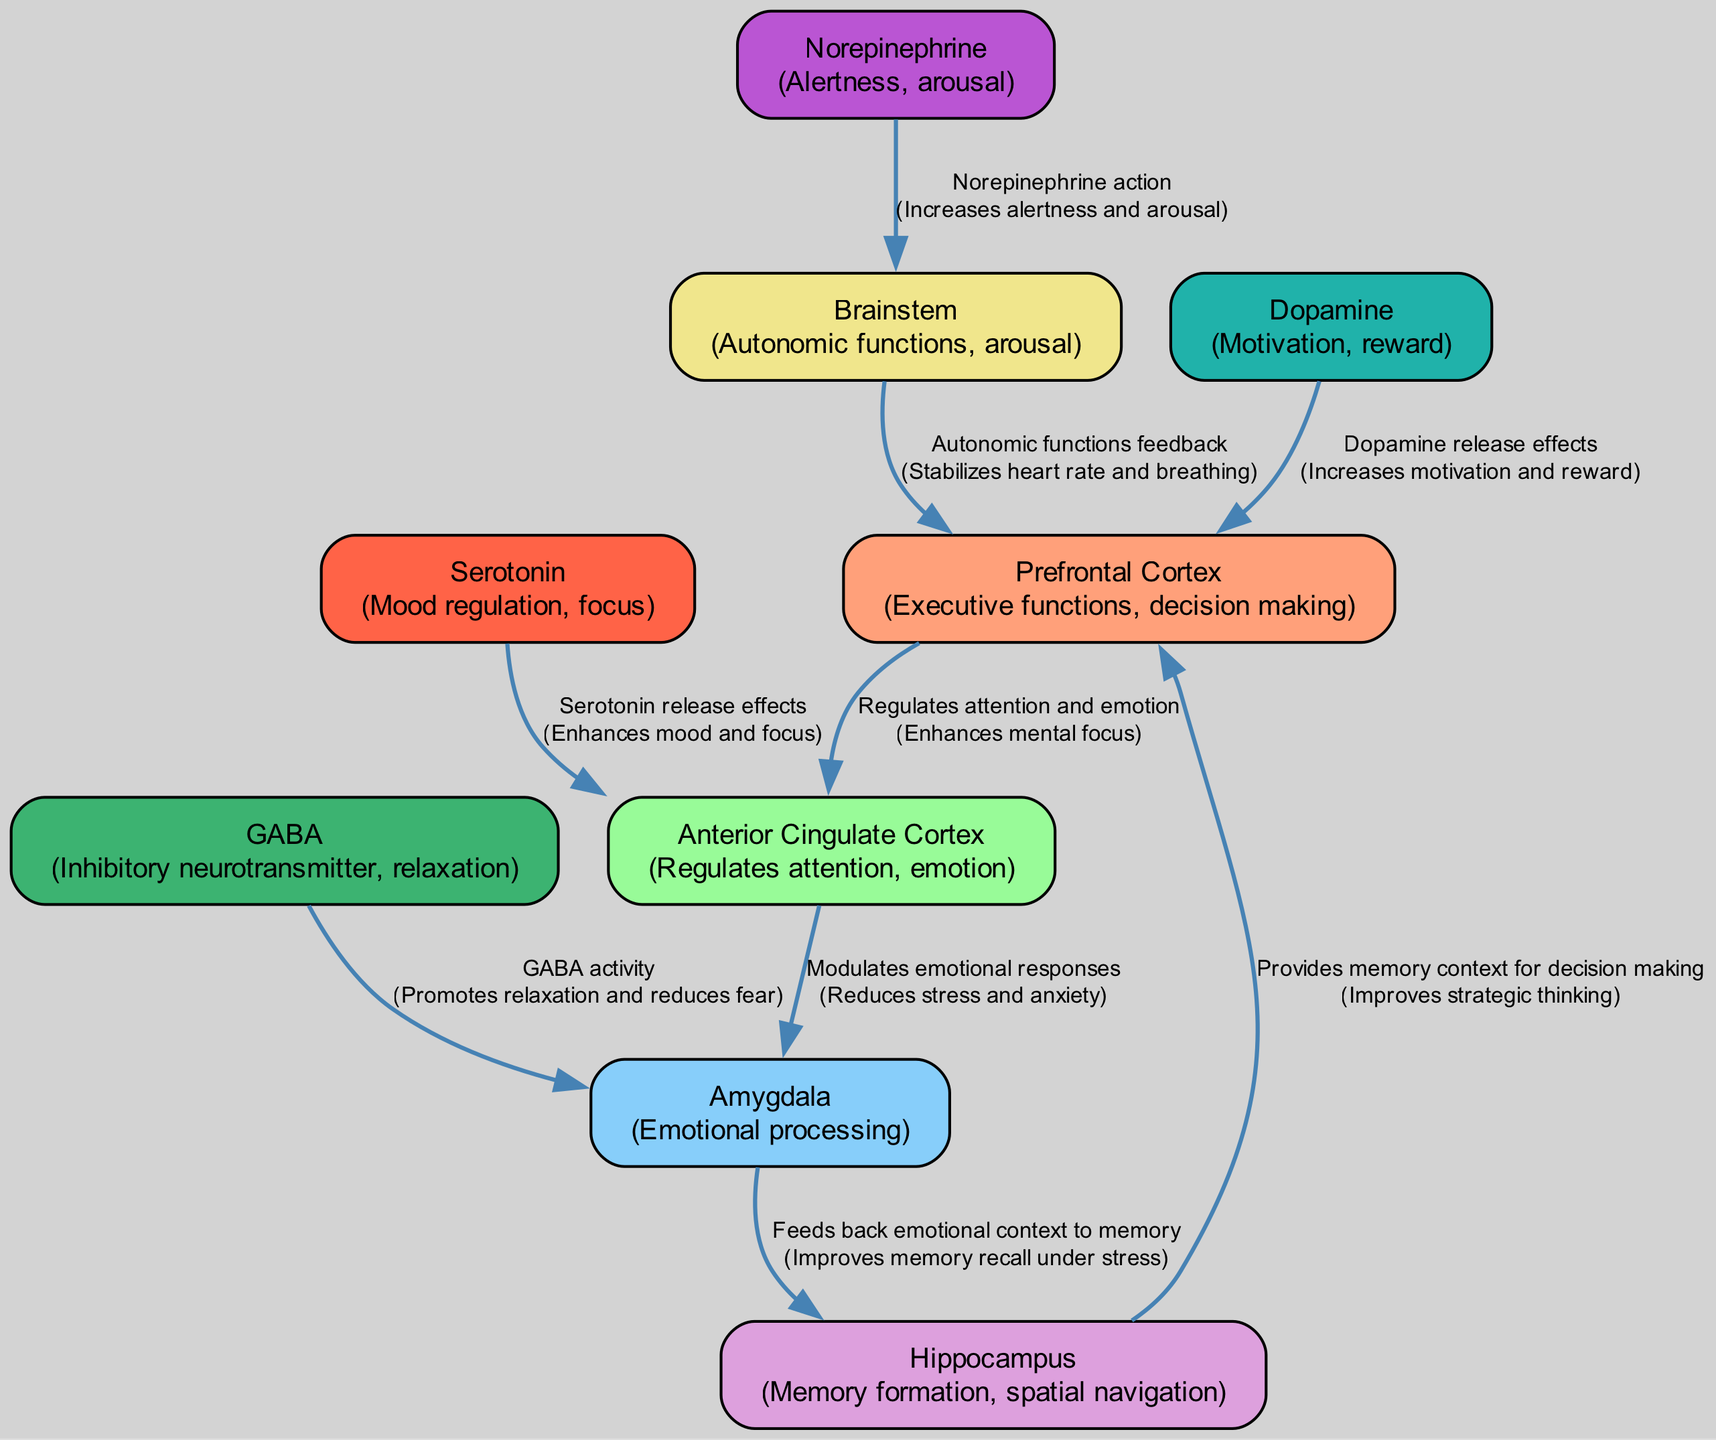What is the function of the Prefrontal Cortex? The Prefrontal Cortex is responsible for executive functions and decision making, as described in the diagram.
Answer: Executive functions, decision making How many nodes are represented in the diagram? The diagram contains 9 nodes, which are the distinct areas or neurotransmitters involved in the neurobiological pathways during meditation.
Answer: 9 What neurotransmitter regulates mood and focus? According to the diagram, Serotonin is the neurotransmitter that regulates mood and focus.
Answer: Serotonin What does the Anterior Cingulate Cortex modulate? The diagram indicates that the Anterior Cingulate Cortex modulates emotional responses.
Answer: Emotional responses Which circuit enhances mental focus? The circuit involving the Prefrontal Cortex and the Anterior Cingulate Cortex enhances mental focus by regulating attention and emotion.
Answer: Prefrontal Cortex to Anterior Cingulate Cortex What feedback does the Brainstem provide? The Brainstem provides autonomic functions feedback, which helps stabilize heart rate and breathing in a meditative state.
Answer: Autonomic functions feedback How does GABA affect the Amygdala? GABA promotes relaxation and reduces fear by acting on the Amygdala, as indicated in the diagram.
Answer: Promotes relaxation and reduces fear Which neurotransmitter is associated with reward and motivation? According to the diagram, Dopamine is the neurotransmitter that is associated with motivation and reward.
Answer: Dopamine What is the relationship between the Amygdala and the Hippocampus described in the diagram? The diagram explains that the Amygdala feeds back emotional context to the Hippocampus, which improves memory recall under stress.
Answer: Feeds back emotional context to memory 